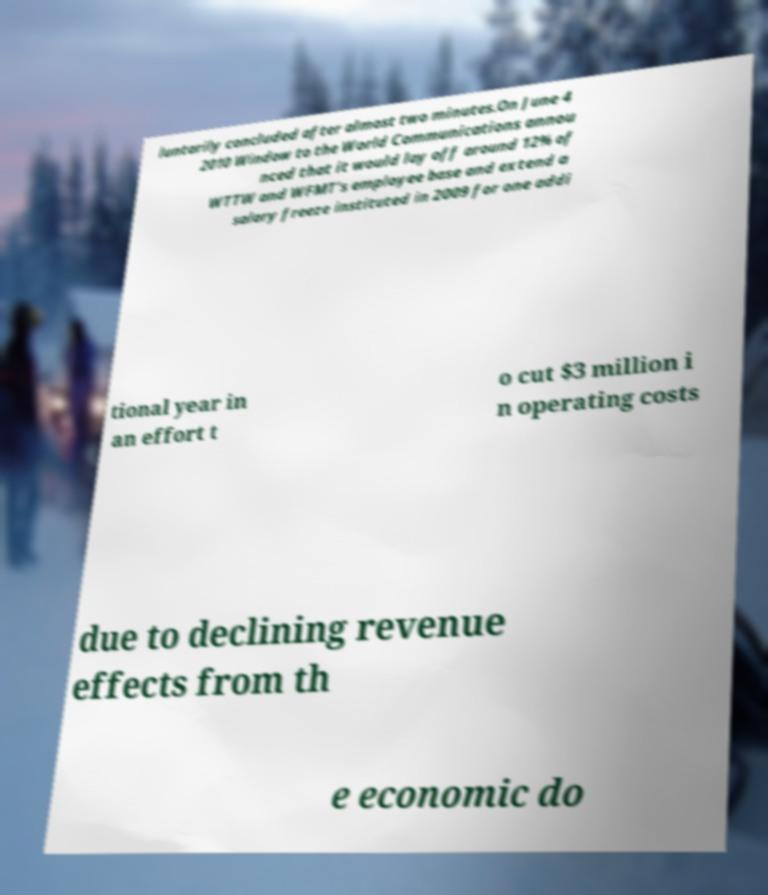Can you read and provide the text displayed in the image?This photo seems to have some interesting text. Can you extract and type it out for me? luntarily concluded after almost two minutes.On June 4 2010 Window to the World Communications annou nced that it would lay off around 12% of WTTW and WFMT's employee base and extend a salary freeze instituted in 2009 for one addi tional year in an effort t o cut $3 million i n operating costs due to declining revenue effects from th e economic do 